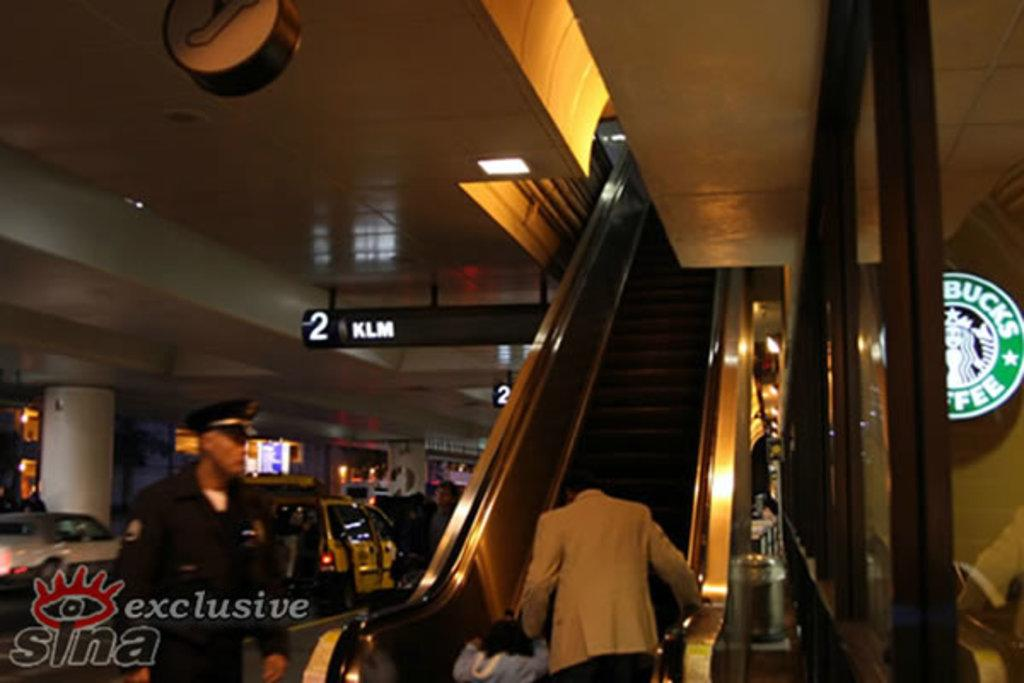<image>
Provide a brief description of the given image. An escalator next to a 2 KLM sign 